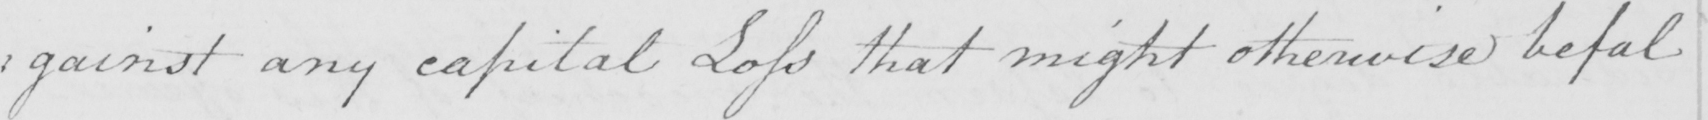What text is written in this handwritten line? : gainst any capital Loss that might otherwise befal 